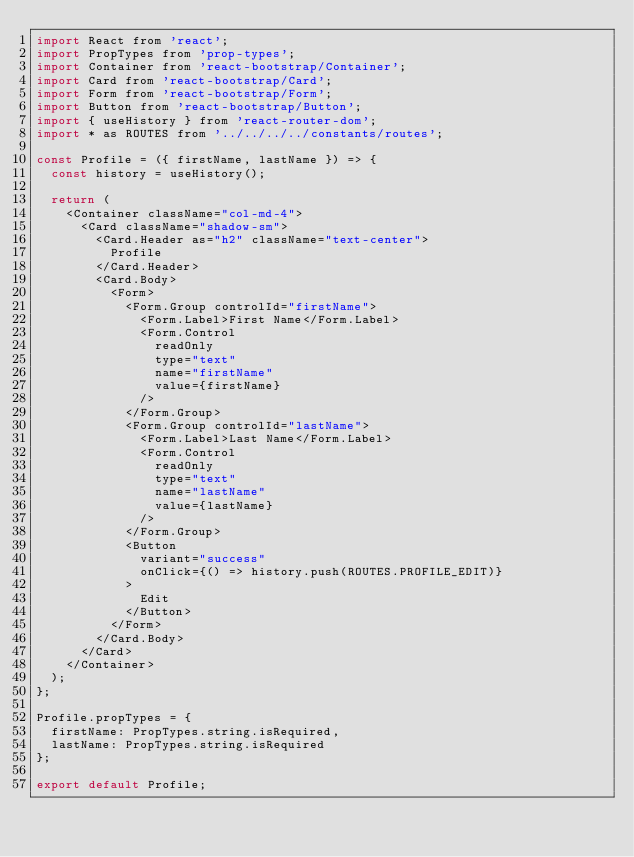Convert code to text. <code><loc_0><loc_0><loc_500><loc_500><_JavaScript_>import React from 'react';
import PropTypes from 'prop-types';
import Container from 'react-bootstrap/Container';
import Card from 'react-bootstrap/Card';
import Form from 'react-bootstrap/Form';
import Button from 'react-bootstrap/Button';
import { useHistory } from 'react-router-dom';
import * as ROUTES from '../../../../constants/routes';

const Profile = ({ firstName, lastName }) => {
  const history = useHistory();

  return (
    <Container className="col-md-4">
      <Card className="shadow-sm">
        <Card.Header as="h2" className="text-center">
          Profile
        </Card.Header>
        <Card.Body>
          <Form>
            <Form.Group controlId="firstName">
              <Form.Label>First Name</Form.Label>
              <Form.Control
                readOnly
                type="text"
                name="firstName"
                value={firstName}
              />
            </Form.Group>
            <Form.Group controlId="lastName">
              <Form.Label>Last Name</Form.Label>
              <Form.Control
                readOnly
                type="text"
                name="lastName"
                value={lastName}
              />
            </Form.Group>
            <Button
              variant="success"
              onClick={() => history.push(ROUTES.PROFILE_EDIT)}
            >
              Edit
            </Button>
          </Form>
        </Card.Body>
      </Card>
    </Container>
  );
};

Profile.propTypes = {
  firstName: PropTypes.string.isRequired,
  lastName: PropTypes.string.isRequired
};

export default Profile;
</code> 